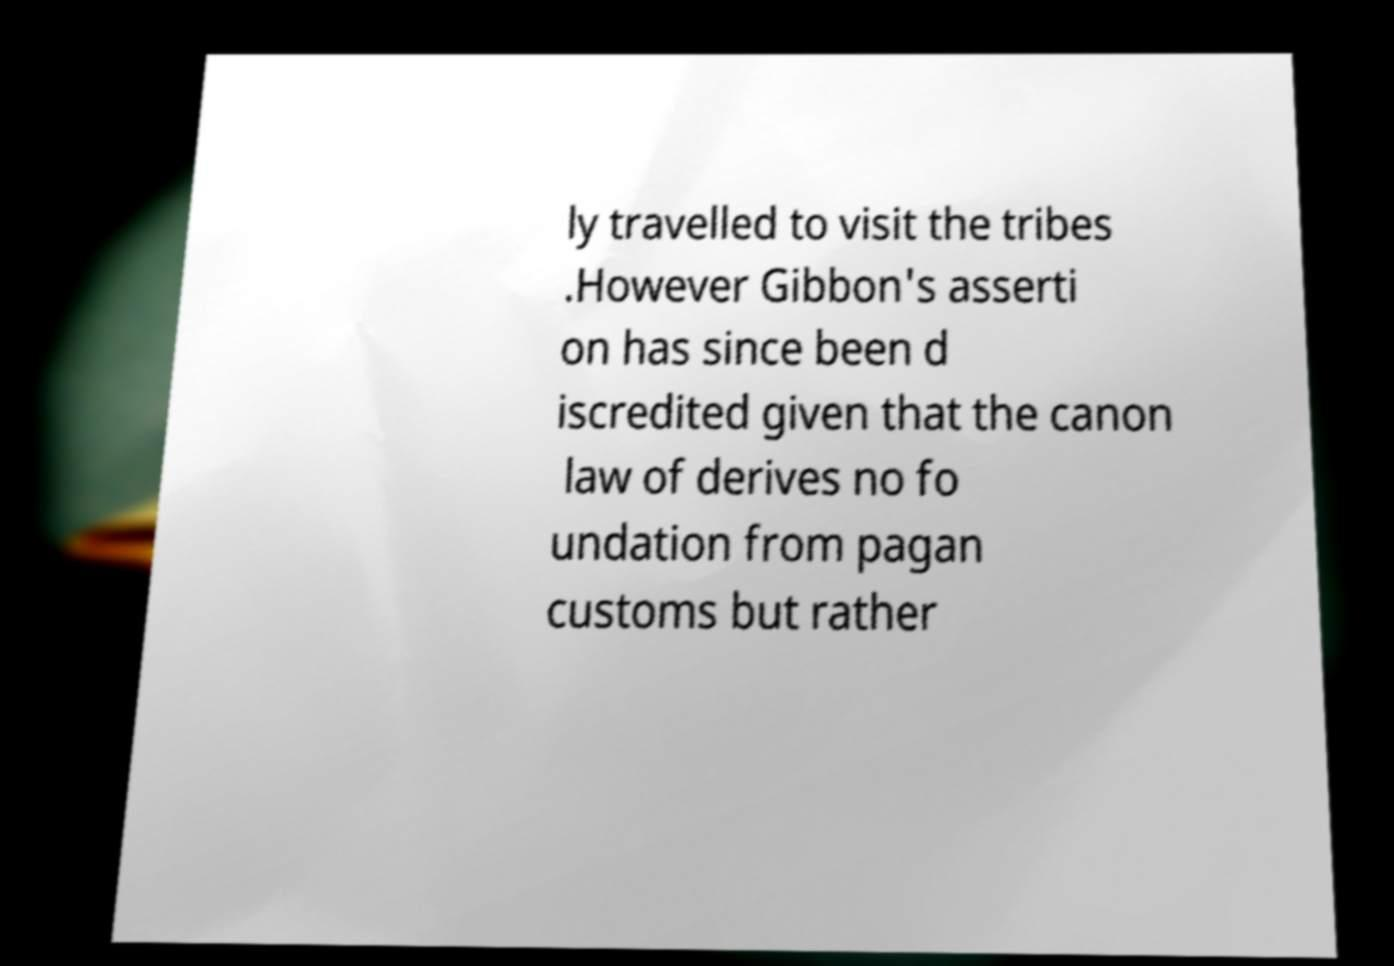Could you assist in decoding the text presented in this image and type it out clearly? ly travelled to visit the tribes .However Gibbon's asserti on has since been d iscredited given that the canon law of derives no fo undation from pagan customs but rather 